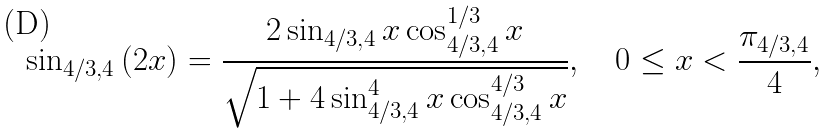Convert formula to latex. <formula><loc_0><loc_0><loc_500><loc_500>\sin _ { 4 / 3 , 4 } { ( 2 x ) } = \frac { 2 \sin _ { 4 / 3 , 4 } { x } \cos _ { 4 / 3 , 4 } ^ { 1 / 3 } { x } } { \sqrt { 1 + 4 \sin _ { 4 / 3 , 4 } ^ { 4 } { x } \cos _ { 4 / 3 , 4 } ^ { 4 / 3 } { x } } } , \quad 0 \leq x < \frac { \pi _ { 4 / 3 , 4 } } { 4 } ,</formula> 